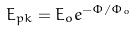Convert formula to latex. <formula><loc_0><loc_0><loc_500><loc_500>E _ { p k } = E _ { o } e ^ { - \Phi / \Phi _ { o } }</formula> 